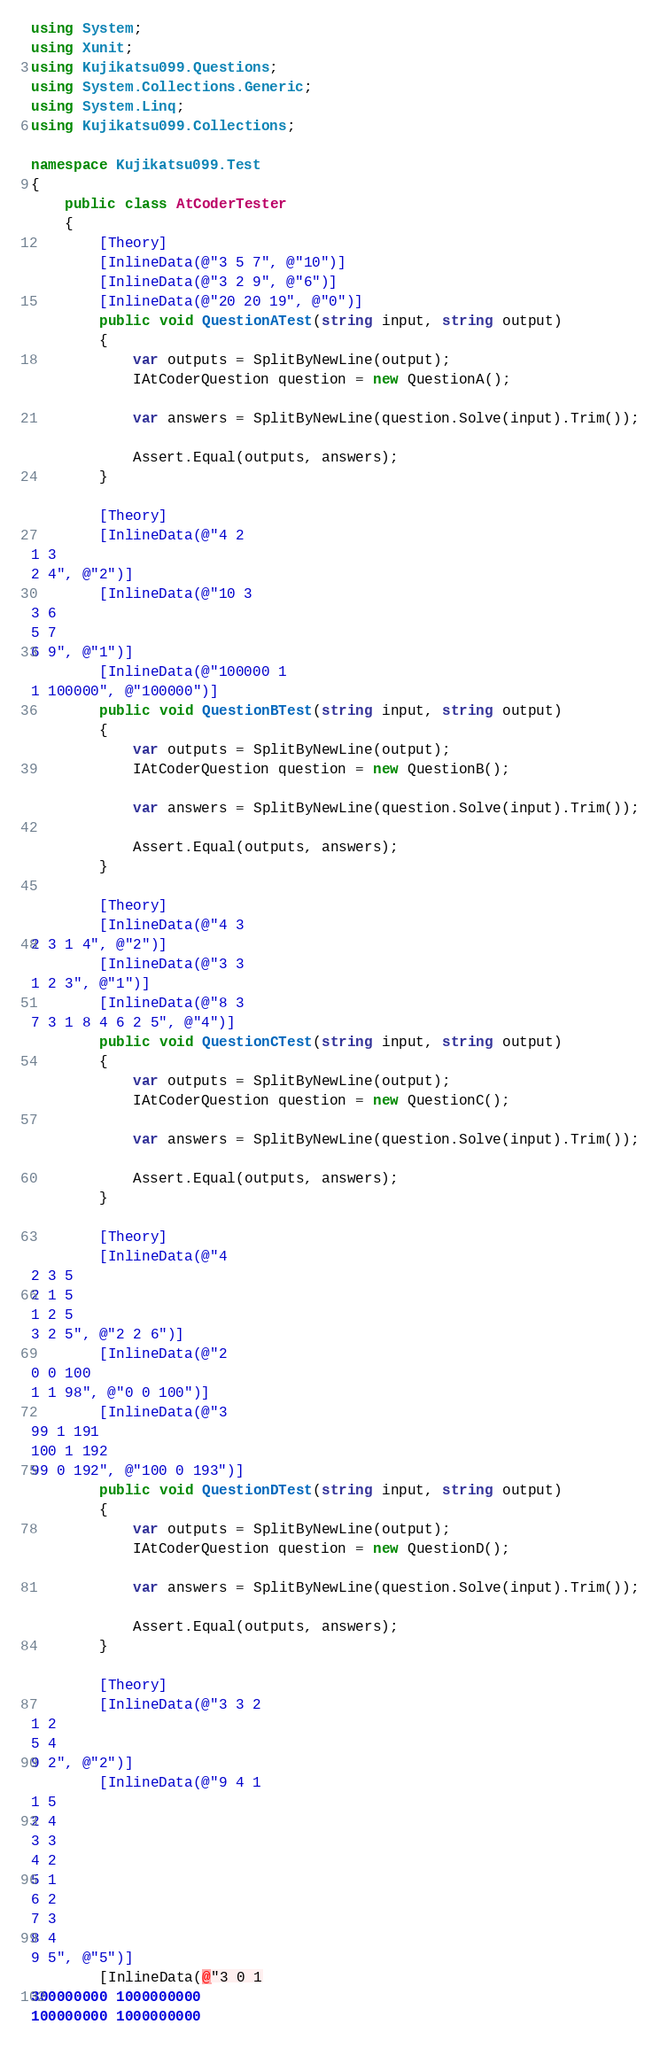<code> <loc_0><loc_0><loc_500><loc_500><_C#_>using System;
using Xunit;
using Kujikatsu099.Questions;
using System.Collections.Generic;
using System.Linq;
using Kujikatsu099.Collections;

namespace Kujikatsu099.Test
{
    public class AtCoderTester
    {
        [Theory]
        [InlineData(@"3 5 7", @"10")]
        [InlineData(@"3 2 9", @"6")]
        [InlineData(@"20 20 19", @"0")]
        public void QuestionATest(string input, string output)
        {
            var outputs = SplitByNewLine(output);
            IAtCoderQuestion question = new QuestionA();

            var answers = SplitByNewLine(question.Solve(input).Trim());

            Assert.Equal(outputs, answers);
        }

        [Theory]
        [InlineData(@"4 2
1 3
2 4", @"2")]
        [InlineData(@"10 3
3 6
5 7
6 9", @"1")]
        [InlineData(@"100000 1
1 100000", @"100000")]
        public void QuestionBTest(string input, string output)
        {
            var outputs = SplitByNewLine(output);
            IAtCoderQuestion question = new QuestionB();

            var answers = SplitByNewLine(question.Solve(input).Trim());

            Assert.Equal(outputs, answers);
        }

        [Theory]
        [InlineData(@"4 3
2 3 1 4", @"2")]
        [InlineData(@"3 3
1 2 3", @"1")]
        [InlineData(@"8 3
7 3 1 8 4 6 2 5", @"4")]
        public void QuestionCTest(string input, string output)
        {
            var outputs = SplitByNewLine(output);
            IAtCoderQuestion question = new QuestionC();

            var answers = SplitByNewLine(question.Solve(input).Trim());

            Assert.Equal(outputs, answers);
        }

        [Theory]
        [InlineData(@"4
2 3 5
2 1 5
1 2 5
3 2 5", @"2 2 6")]
        [InlineData(@"2
0 0 100
1 1 98", @"0 0 100")]
        [InlineData(@"3
99 1 191
100 1 192
99 0 192", @"100 0 193")]
        public void QuestionDTest(string input, string output)
        {
            var outputs = SplitByNewLine(output);
            IAtCoderQuestion question = new QuestionD();

            var answers = SplitByNewLine(question.Solve(input).Trim());

            Assert.Equal(outputs, answers);
        }

        [Theory]
        [InlineData(@"3 3 2
1 2
5 4
9 2", @"2")]
        [InlineData(@"9 4 1
1 5
2 4
3 3
4 2
5 1
6 2
7 3
8 4
9 5", @"5")]
        [InlineData(@"3 0 1
300000000 1000000000
100000000 1000000000</code> 